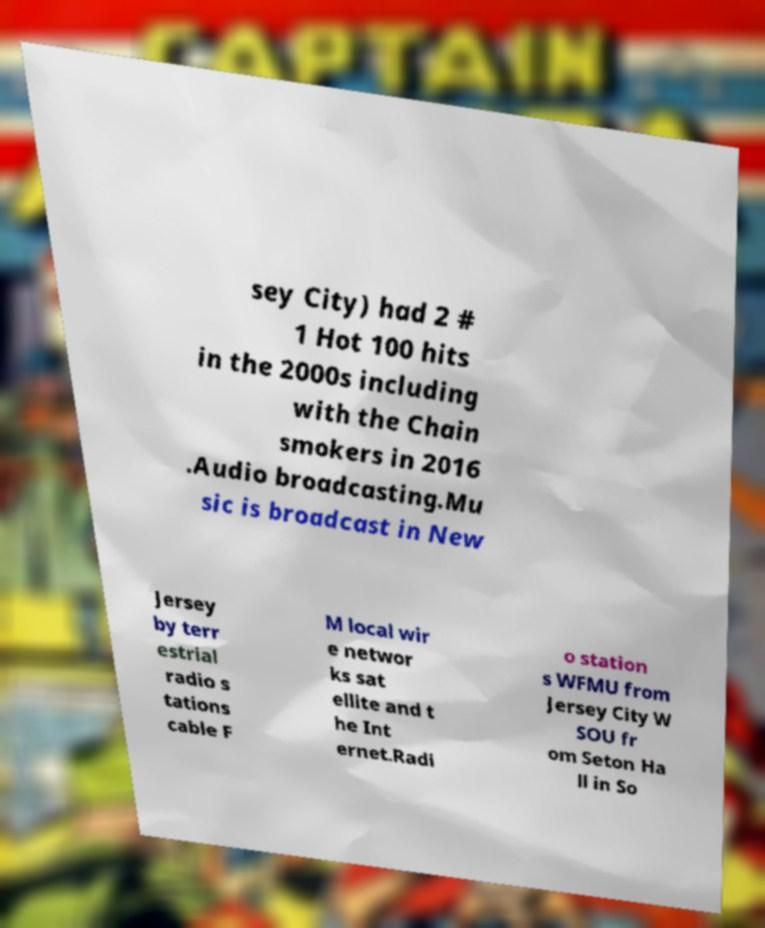I need the written content from this picture converted into text. Can you do that? sey City) had 2 # 1 Hot 100 hits in the 2000s including with the Chain smokers in 2016 .Audio broadcasting.Mu sic is broadcast in New Jersey by terr estrial radio s tations cable F M local wir e networ ks sat ellite and t he Int ernet.Radi o station s WFMU from Jersey City W SOU fr om Seton Ha ll in So 